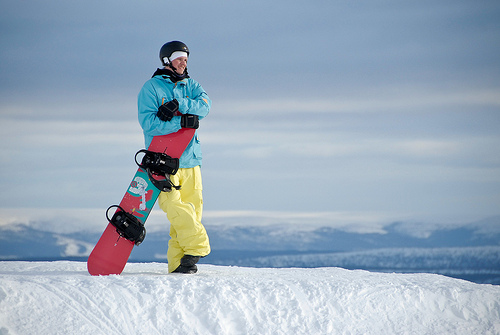How big is the sky behind the snow? The sky, which extends to the horizon behind the snowy landscape, appears vast and seemingly limitless as is typical for skies observed from open areas. 